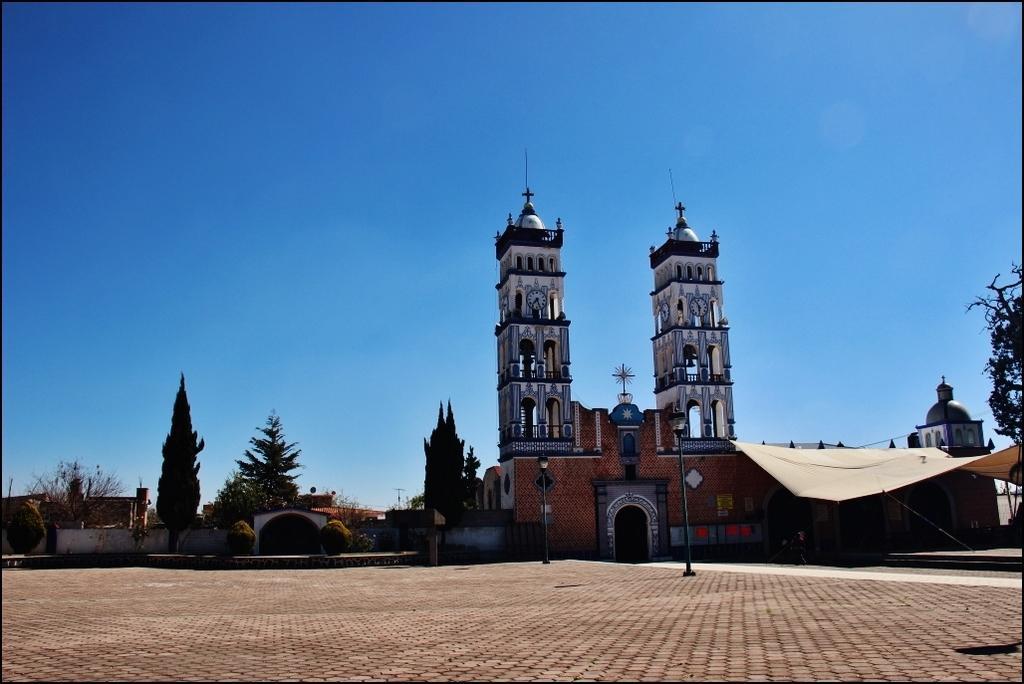Can you describe this image briefly? In the foreground of this image, on the bottom, there is pavement and few poles on it. In the background, there are trees, shrubs, a shelter, building, tent and a tree on the right. On the top, there is the sky. 